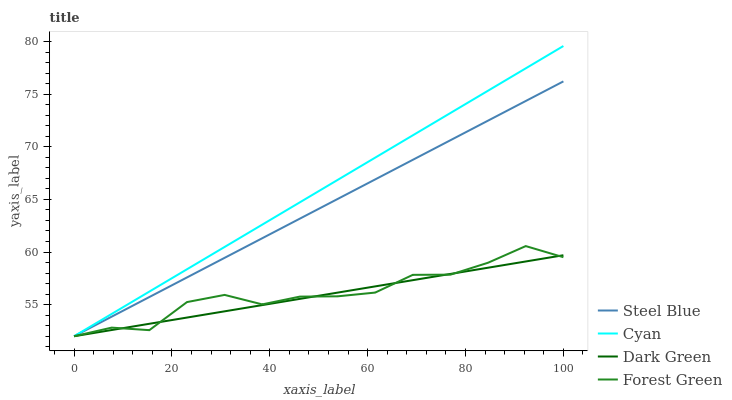Does Forest Green have the minimum area under the curve?
Answer yes or no. No. Does Forest Green have the maximum area under the curve?
Answer yes or no. No. Is Steel Blue the smoothest?
Answer yes or no. No. Is Steel Blue the roughest?
Answer yes or no. No. Does Forest Green have the highest value?
Answer yes or no. No. 